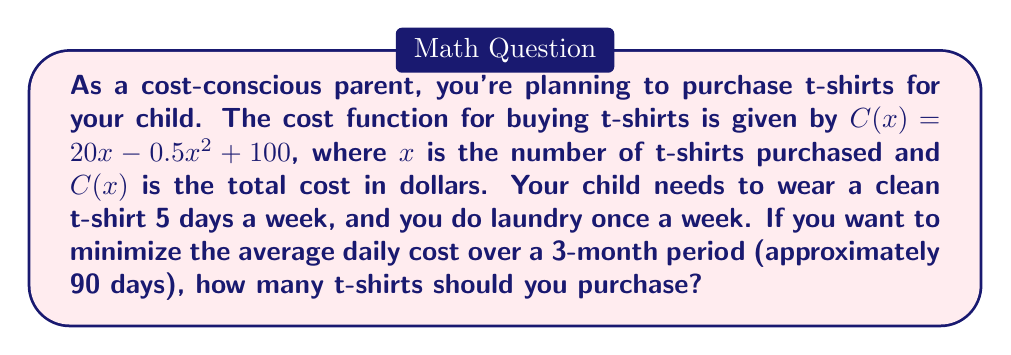Help me with this question. Let's approach this step-by-step:

1) First, we need to determine the minimum number of t-shirts required. Since the child needs 5 clean shirts per week and laundry is done once a week, the minimum number is 5.

2) To find the optimal number of t-shirts, we need to minimize the average daily cost over 90 days. The average daily cost is given by:

   $$ \text{Average Daily Cost} = \frac{\text{Total Cost}}{\text{Number of Days}} = \frac{C(x)}{90} $$

3) Substituting the cost function:

   $$ \text{Average Daily Cost} = \frac{20x - 0.5x^2 + 100}{90} $$

4) To minimize this, we need to find the value of $x$ where the derivative of this function equals zero:

   $$ \frac{d}{dx}\left(\frac{20x - 0.5x^2 + 100}{90}\right) = \frac{20 - x}{90} = 0 $$

5) Solving this equation:

   $$ 20 - x = 0 $$
   $$ x = 20 $$

6) The second derivative is negative ($-\frac{1}{90}$), confirming this is a minimum.

7) However, we need to check if this makes practical sense. Buying 20 t-shirts for 5 days of wear per week might be excessive.

8) Let's calculate the total cost for different numbers of t-shirts:
   For 5 t-shirts: $C(5) = 20(5) - 0.5(5^2) + 100 = 187.5$
   For 10 t-shirts: $C(10) = 20(10) - 0.5(10^2) + 100 = 250$
   For 15 t-shirts: $C(15) = 20(15) - 0.5(15^2) + 100 = 287.5$
   For 20 t-shirts: $C(20) = 20(20) - 0.5(20^2) + 100 = 300$

9) The average daily costs for these options are:
   5 t-shirts: $187.5 / 90 = 2.08$ per day
   10 t-shirts: $250 / 90 = 2.78$ per day
   15 t-shirts: $287.5 / 90 = 3.19$ per day
   20 t-shirts: $300 / 90 = 3.33$ per day

10) From a practical standpoint, purchasing 5 t-shirts is the most cost-effective option that meets the minimum requirement.
Answer: The optimal number of t-shirts to purchase is 5, which results in the lowest average daily cost of $2.08 over the 3-month period while meeting the minimum requirement of 5 clean shirts per week. 